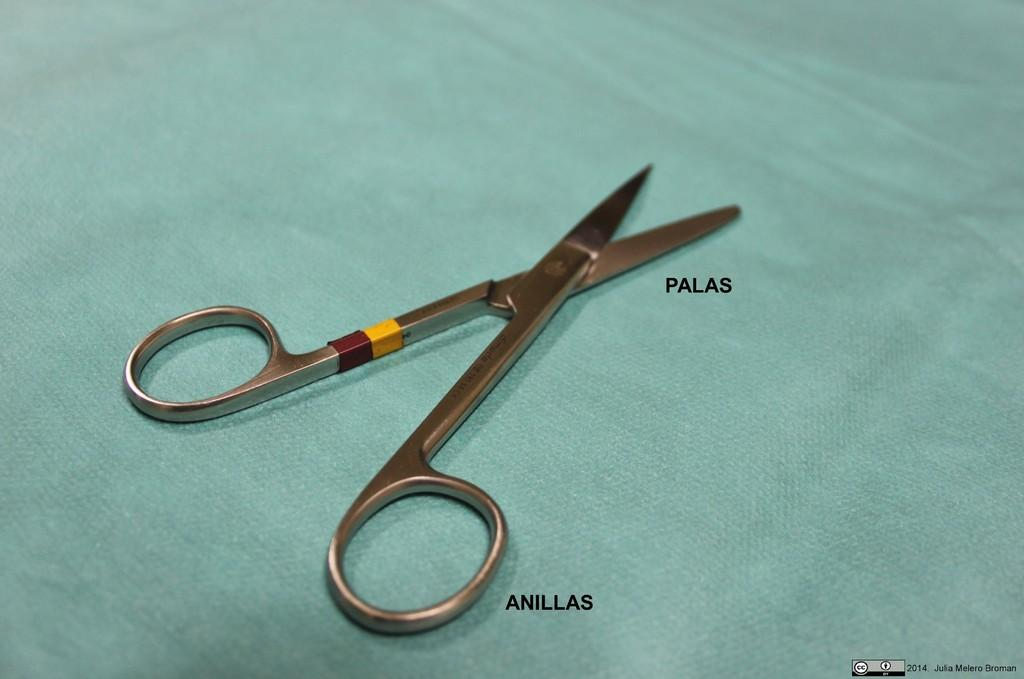What object can be seen in the picture? There is a scissor in the picture. What else is present near the scissor? There is writing beside the scissor. Can you describe the writing in the right bottom corner of the image? There is writing in the right bottom corner of the image. How many cherries are on the scissor in the image? There are no cherries present in the image. What is the distance between the scissor and the writing in the right bottom corner of the image? The distance between the scissor and the writing in the right bottom corner cannot be determined from the image alone. --- Facts: 1. There is a person sitting on a chair in the image. 2. The person is holding a book. 3. The book has a blue cover. 4. There is a table next to the chair. 5. There is a lamp on the table. Absurd Topics: parrot, ocean, dance Conversation: What is the person in the image doing? The person is sitting on a chair in the image. What is the person holding while sitting on the chair? The person is holding a book. Can you describe the book's appearance? The book has a blue cover. What is present next to the chair in the image? There is a table next to the chair. What object is on the table? There is a lamp on the table. Reasoning: Let's think step by step in order to produce the conversation. We start by identifying the main subject in the image, which is the person sitting on a chair. Then, we expand the conversation to include other details about the image, such as the book the person is holding, the color of the book's cover, and the presence of a table and lamp. Each question is designed to elicit a specific detail about the image that is known from the provided facts. Absurd Question/Answer: Can you tell me how many parrots are sitting on the person's shoulder in the image? There are no parrots present in the image. What type of dance is the person performing in the image? There is no indication of dancing in the image; the person is sitting and holding a book. 